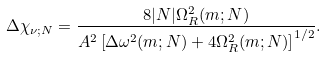Convert formula to latex. <formula><loc_0><loc_0><loc_500><loc_500>\Delta \chi _ { \nu ; N } = \frac { 8 | N | \Omega _ { R } ^ { 2 } ( m ; N ) } { A ^ { 2 } \left [ \Delta \omega ^ { 2 } ( m ; N ) + 4 \Omega _ { R } ^ { 2 } ( m ; N ) \right ] ^ { 1 / 2 } } .</formula> 